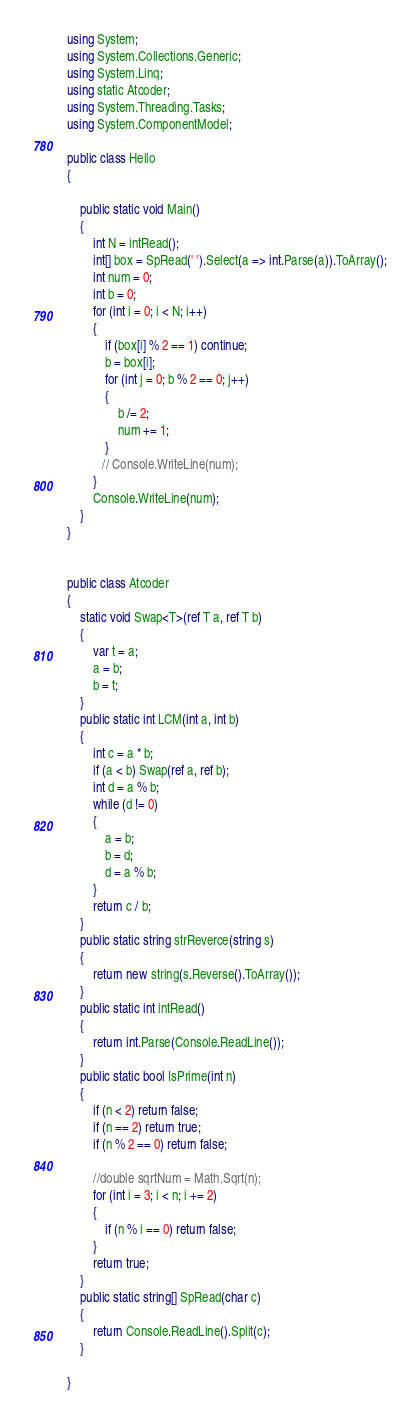Convert code to text. <code><loc_0><loc_0><loc_500><loc_500><_C#_>using System;
using System.Collections.Generic;
using System.Linq;
using static Atcoder;
using System.Threading.Tasks;
using System.ComponentModel;

public class Hello
{

    public static void Main()
    {
        int N = intRead();
        int[] box = SpRead(' ').Select(a => int.Parse(a)).ToArray();
        int num = 0;
        int b = 0;
        for (int i = 0; i < N; i++)
        {
            if (box[i] % 2 == 1) continue;
            b = box[i];
            for (int j = 0; b % 2 == 0; j++)
            {
                b /= 2;
                num += 1;
            }
           // Console.WriteLine(num);
        }
        Console.WriteLine(num);
    }
}


public class Atcoder
{
    static void Swap<T>(ref T a, ref T b)
    {
        var t = a;
        a = b;
        b = t;
    }
    public static int LCM(int a, int b)
    {
        int c = a * b;
        if (a < b) Swap(ref a, ref b);
        int d = a % b;
        while (d != 0)
        {
            a = b;
            b = d;
            d = a % b;
        }
        return c / b;
    }
    public static string strReverce(string s)
    {
        return new string(s.Reverse().ToArray());
    }
    public static int intRead()
    {
        return int.Parse(Console.ReadLine());
    }
    public static bool IsPrime(int n)
    {
        if (n < 2) return false;
        if (n == 2) return true;
        if (n % 2 == 0) return false;

        //double sqrtNum = Math.Sqrt(n);
        for (int i = 3; i < n; i += 2)
        {
            if (n % i == 0) return false;
        }
        return true;
    }
    public static string[] SpRead(char c)
    {
        return Console.ReadLine().Split(c);
    }

}
</code> 